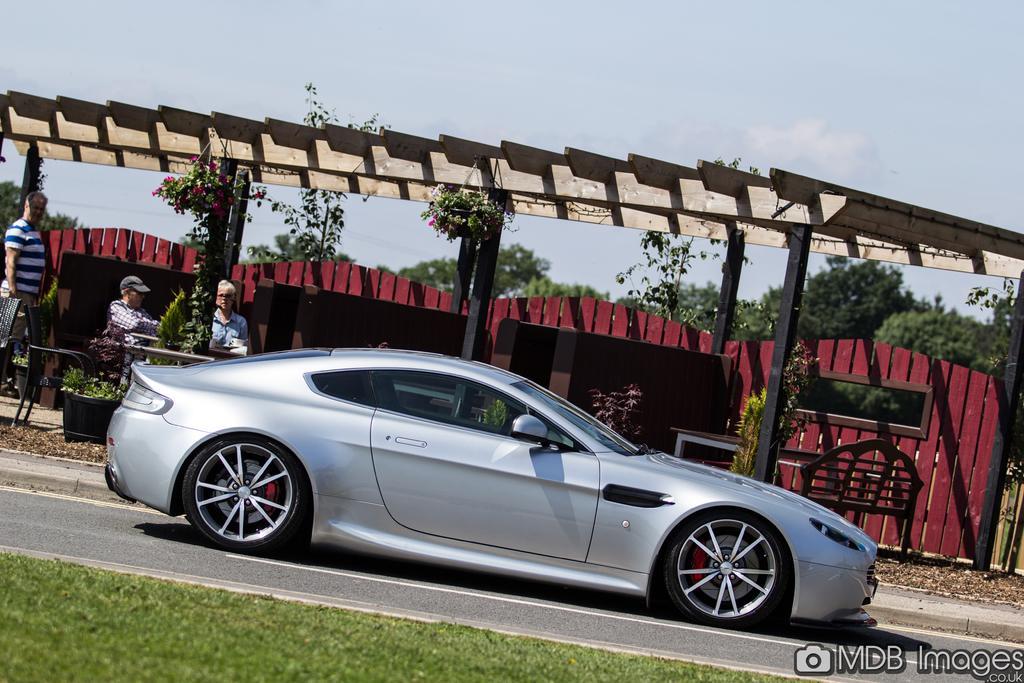Describe this image in one or two sentences. In this image I can see in the middle there is a car on the road, on the left side three persons are there. In the middle there is a wooden wall, at the back side there are trees. At the top it is the sky, in the right hand side bottom there is the water mark. 